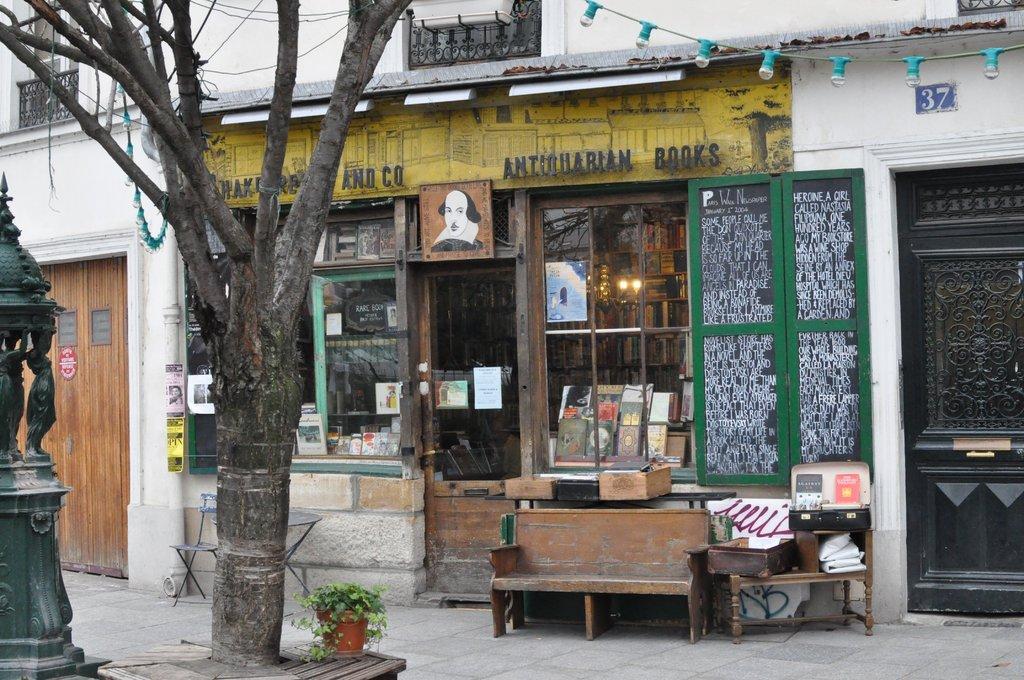Please provide a concise description of this image. In this image I can see tree trunk, branches, a tree, a plant in a pot, a bench, a table, a chair, a building, few books and over here I can see something is written. I can also see number of lights. 